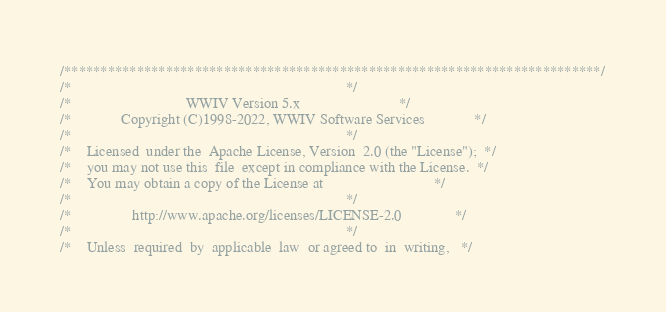Convert code to text. <code><loc_0><loc_0><loc_500><loc_500><_C_>/**************************************************************************/
/*                                                                        */
/*                              WWIV Version 5.x                          */
/*             Copyright (C)1998-2022, WWIV Software Services             */
/*                                                                        */
/*    Licensed  under the  Apache License, Version  2.0 (the "License");  */
/*    you may not use this  file  except in compliance with the License.  */
/*    You may obtain a copy of the License at                             */
/*                                                                        */
/*                http://www.apache.org/licenses/LICENSE-2.0              */
/*                                                                        */
/*    Unless  required  by  applicable  law  or agreed to  in  writing,   */</code> 